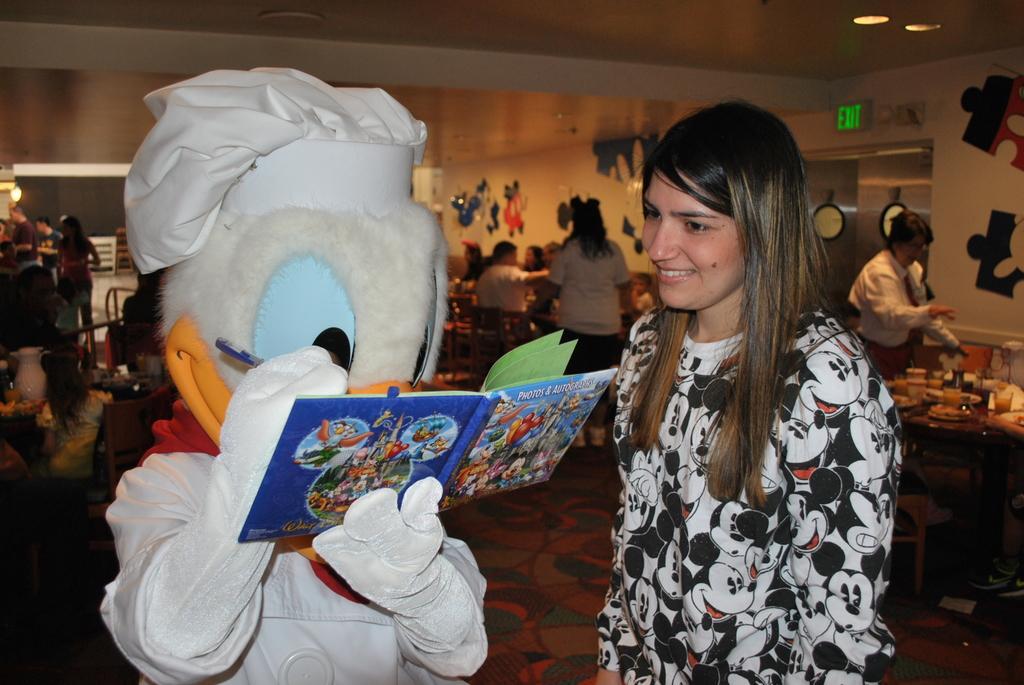Please provide a concise description of this image. In this image we can see a person wearing costume holding pen and a book in his hands, we can also see a group of people. Some people are standing. On the left and right side of the image we can see some objects placed on the tables. In the background, we can see doors, some paintings on the wall and some lights. 